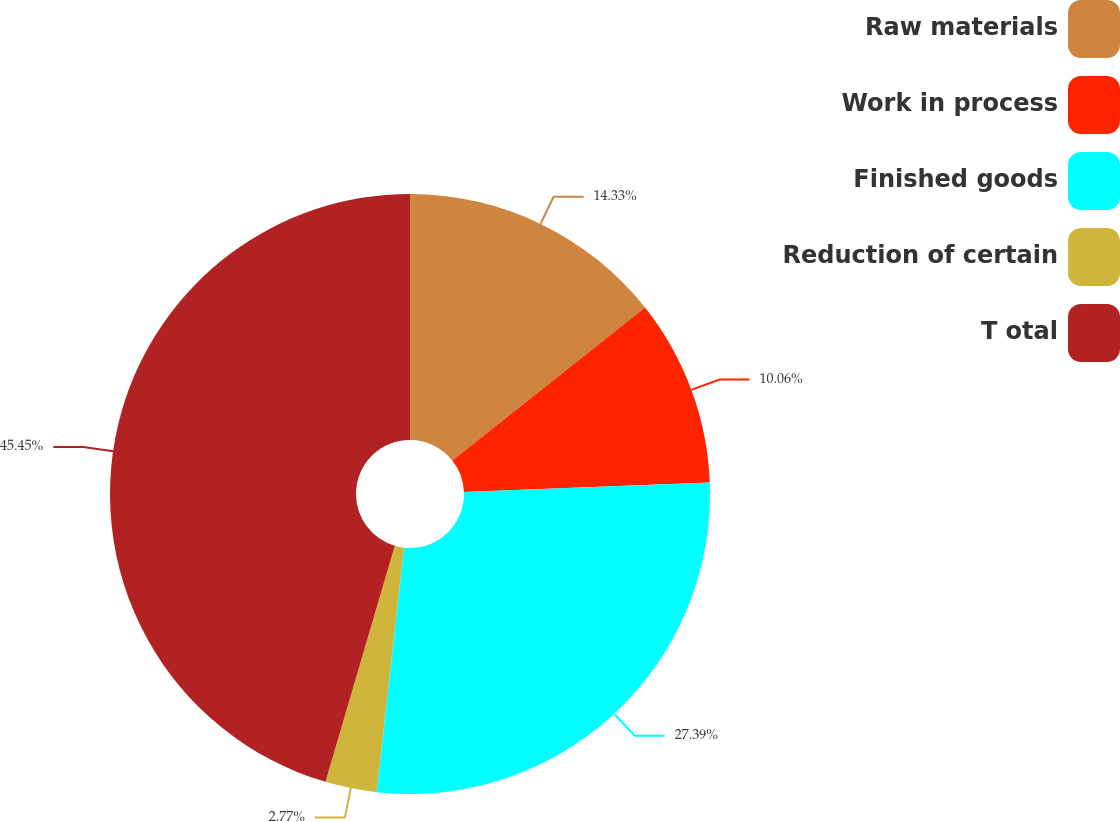Convert chart to OTSL. <chart><loc_0><loc_0><loc_500><loc_500><pie_chart><fcel>Raw materials<fcel>Work in process<fcel>Finished goods<fcel>Reduction of certain<fcel>T otal<nl><fcel>14.33%<fcel>10.06%<fcel>27.39%<fcel>2.77%<fcel>45.46%<nl></chart> 